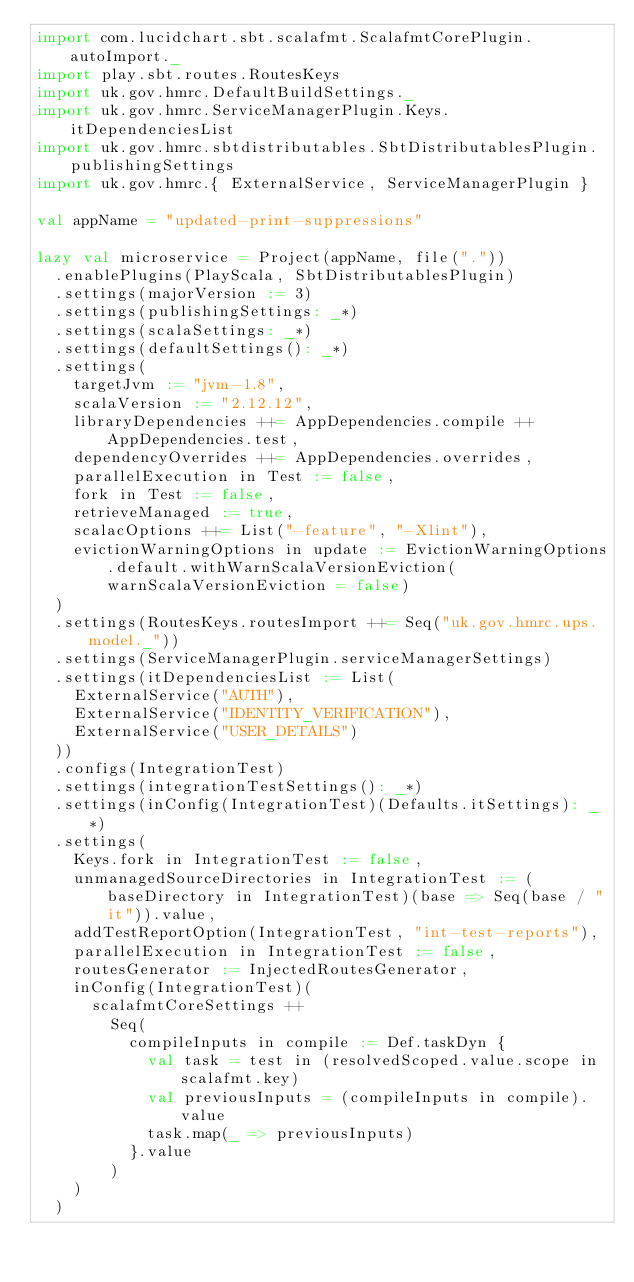Convert code to text. <code><loc_0><loc_0><loc_500><loc_500><_Scala_>import com.lucidchart.sbt.scalafmt.ScalafmtCorePlugin.autoImport._
import play.sbt.routes.RoutesKeys
import uk.gov.hmrc.DefaultBuildSettings._
import uk.gov.hmrc.ServiceManagerPlugin.Keys.itDependenciesList
import uk.gov.hmrc.sbtdistributables.SbtDistributablesPlugin.publishingSettings
import uk.gov.hmrc.{ ExternalService, ServiceManagerPlugin }

val appName = "updated-print-suppressions"

lazy val microservice = Project(appName, file("."))
  .enablePlugins(PlayScala, SbtDistributablesPlugin)
  .settings(majorVersion := 3)
  .settings(publishingSettings: _*)
  .settings(scalaSettings: _*)
  .settings(defaultSettings(): _*)
  .settings(
    targetJvm := "jvm-1.8",
    scalaVersion := "2.12.12",
    libraryDependencies ++= AppDependencies.compile ++ AppDependencies.test,
    dependencyOverrides ++= AppDependencies.overrides,
    parallelExecution in Test := false,
    fork in Test := false,
    retrieveManaged := true,
    scalacOptions ++= List("-feature", "-Xlint"),
    evictionWarningOptions in update := EvictionWarningOptions.default.withWarnScalaVersionEviction(warnScalaVersionEviction = false)
  )
  .settings(RoutesKeys.routesImport ++= Seq("uk.gov.hmrc.ups.model._"))
  .settings(ServiceManagerPlugin.serviceManagerSettings)
  .settings(itDependenciesList := List(
    ExternalService("AUTH"),
    ExternalService("IDENTITY_VERIFICATION"),
    ExternalService("USER_DETAILS")
  ))
  .configs(IntegrationTest)
  .settings(integrationTestSettings(): _*)
  .settings(inConfig(IntegrationTest)(Defaults.itSettings): _*)
  .settings(
    Keys.fork in IntegrationTest := false,
    unmanagedSourceDirectories in IntegrationTest := (baseDirectory in IntegrationTest)(base => Seq(base / "it")).value,
    addTestReportOption(IntegrationTest, "int-test-reports"),
    parallelExecution in IntegrationTest := false,
    routesGenerator := InjectedRoutesGenerator,
    inConfig(IntegrationTest)(
      scalafmtCoreSettings ++
        Seq(
          compileInputs in compile := Def.taskDyn {
            val task = test in (resolvedScoped.value.scope in scalafmt.key)
            val previousInputs = (compileInputs in compile).value
            task.map(_ => previousInputs)
          }.value
        )
    )
  )
</code> 